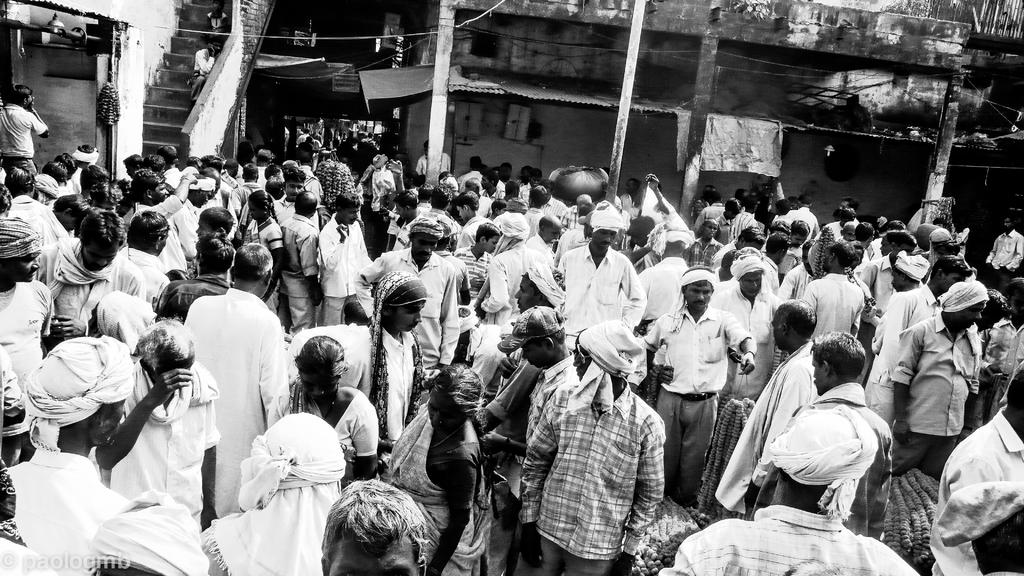What is happening in the image? There are persons standing in the image. What can be seen in the background of the image? There are buildings and steps in the background of the image. What type of linen is being used to cover the hand in the image? There is no linen or hand present in the image. What level of difficulty is the task being performed by the persons in the image? The image does not provide information about the difficulty level of any task being performed by the persons. 